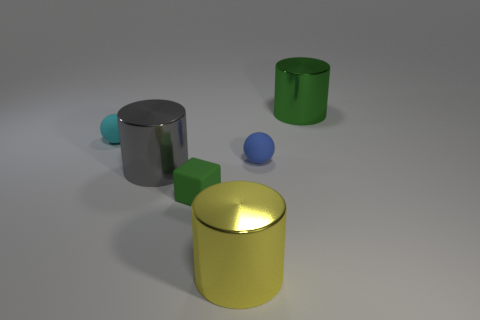What material is the thing that is the same color as the tiny matte block?
Keep it short and to the point. Metal. What is the yellow cylinder made of?
Your response must be concise. Metal. There is a gray cylinder that is the same size as the green metallic thing; what is it made of?
Provide a succinct answer. Metal. Are there any red objects that have the same size as the cyan thing?
Your answer should be very brief. No. Are there the same number of big gray metallic things that are behind the tiny cyan thing and big yellow things that are to the right of the blue matte object?
Ensure brevity in your answer.  Yes. Is the number of large gray metallic objects greater than the number of big cyan cubes?
Ensure brevity in your answer.  Yes. How many matte things are either yellow things or big spheres?
Make the answer very short. 0. What number of other rubber blocks have the same color as the rubber cube?
Provide a succinct answer. 0. What material is the ball that is behind the small blue ball on the right side of the large thing that is on the left side of the large yellow metallic object?
Provide a succinct answer. Rubber. There is a big object left of the green object to the left of the green cylinder; what color is it?
Keep it short and to the point. Gray. 